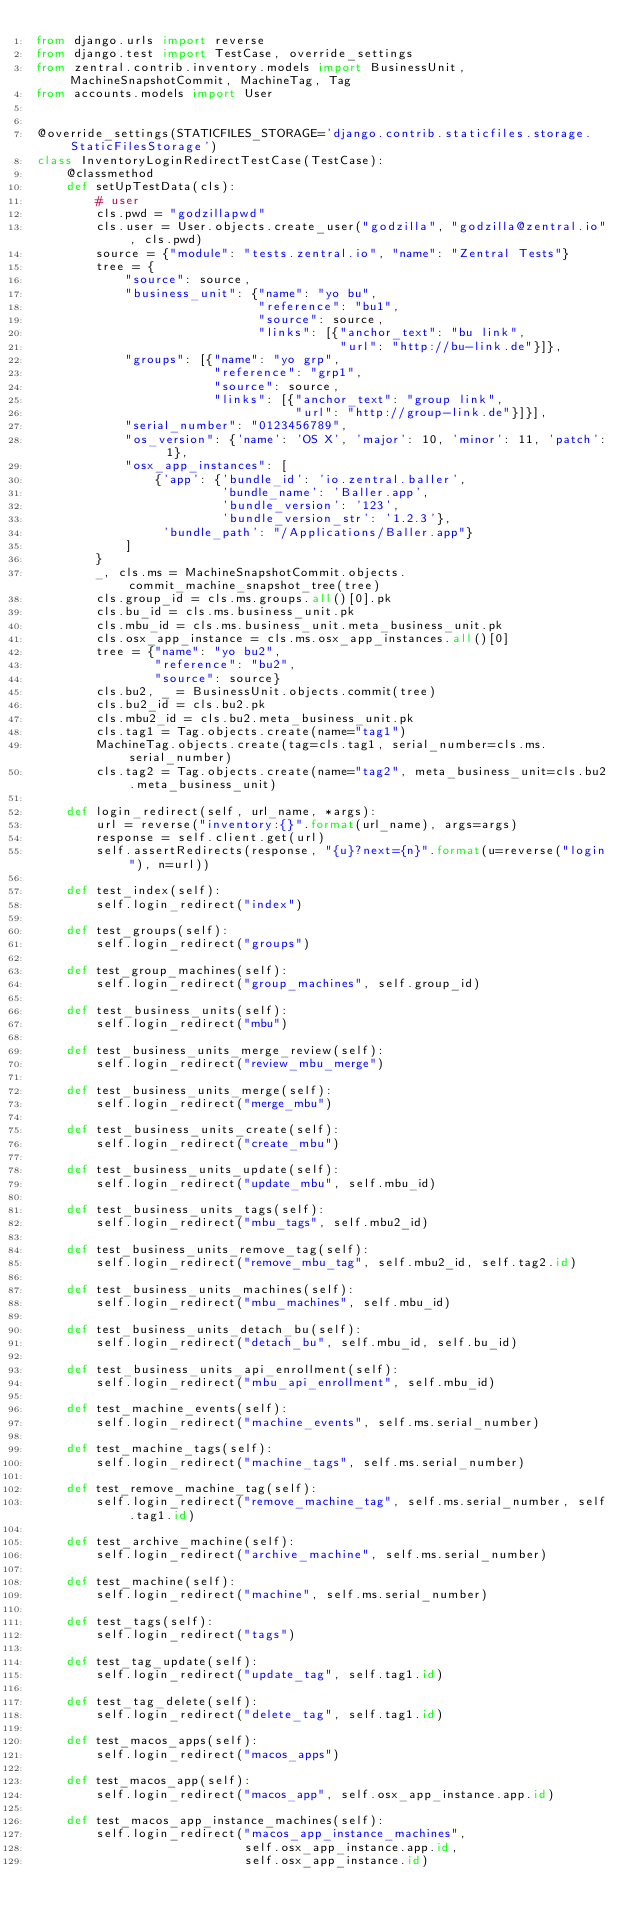Convert code to text. <code><loc_0><loc_0><loc_500><loc_500><_Python_>from django.urls import reverse
from django.test import TestCase, override_settings
from zentral.contrib.inventory.models import BusinessUnit, MachineSnapshotCommit, MachineTag, Tag
from accounts.models import User


@override_settings(STATICFILES_STORAGE='django.contrib.staticfiles.storage.StaticFilesStorage')
class InventoryLoginRedirectTestCase(TestCase):
    @classmethod
    def setUpTestData(cls):
        # user
        cls.pwd = "godzillapwd"
        cls.user = User.objects.create_user("godzilla", "godzilla@zentral.io", cls.pwd)
        source = {"module": "tests.zentral.io", "name": "Zentral Tests"}
        tree = {
            "source": source,
            "business_unit": {"name": "yo bu",
                              "reference": "bu1",
                              "source": source,
                              "links": [{"anchor_text": "bu link",
                                         "url": "http://bu-link.de"}]},
            "groups": [{"name": "yo grp",
                        "reference": "grp1",
                        "source": source,
                        "links": [{"anchor_text": "group link",
                                   "url": "http://group-link.de"}]}],
            "serial_number": "0123456789",
            "os_version": {'name': 'OS X', 'major': 10, 'minor': 11, 'patch': 1},
            "osx_app_instances": [
                {'app': {'bundle_id': 'io.zentral.baller',
                         'bundle_name': 'Baller.app',
                         'bundle_version': '123',
                         'bundle_version_str': '1.2.3'},
                 'bundle_path': "/Applications/Baller.app"}
            ]
        }
        _, cls.ms = MachineSnapshotCommit.objects.commit_machine_snapshot_tree(tree)
        cls.group_id = cls.ms.groups.all()[0].pk
        cls.bu_id = cls.ms.business_unit.pk
        cls.mbu_id = cls.ms.business_unit.meta_business_unit.pk
        cls.osx_app_instance = cls.ms.osx_app_instances.all()[0]
        tree = {"name": "yo bu2",
                "reference": "bu2",
                "source": source}
        cls.bu2, _ = BusinessUnit.objects.commit(tree)
        cls.bu2_id = cls.bu2.pk
        cls.mbu2_id = cls.bu2.meta_business_unit.pk
        cls.tag1 = Tag.objects.create(name="tag1")
        MachineTag.objects.create(tag=cls.tag1, serial_number=cls.ms.serial_number)
        cls.tag2 = Tag.objects.create(name="tag2", meta_business_unit=cls.bu2.meta_business_unit)

    def login_redirect(self, url_name, *args):
        url = reverse("inventory:{}".format(url_name), args=args)
        response = self.client.get(url)
        self.assertRedirects(response, "{u}?next={n}".format(u=reverse("login"), n=url))

    def test_index(self):
        self.login_redirect("index")

    def test_groups(self):
        self.login_redirect("groups")

    def test_group_machines(self):
        self.login_redirect("group_machines", self.group_id)

    def test_business_units(self):
        self.login_redirect("mbu")

    def test_business_units_merge_review(self):
        self.login_redirect("review_mbu_merge")

    def test_business_units_merge(self):
        self.login_redirect("merge_mbu")

    def test_business_units_create(self):
        self.login_redirect("create_mbu")

    def test_business_units_update(self):
        self.login_redirect("update_mbu", self.mbu_id)

    def test_business_units_tags(self):
        self.login_redirect("mbu_tags", self.mbu2_id)

    def test_business_units_remove_tag(self):
        self.login_redirect("remove_mbu_tag", self.mbu2_id, self.tag2.id)

    def test_business_units_machines(self):
        self.login_redirect("mbu_machines", self.mbu_id)

    def test_business_units_detach_bu(self):
        self.login_redirect("detach_bu", self.mbu_id, self.bu_id)

    def test_business_units_api_enrollment(self):
        self.login_redirect("mbu_api_enrollment", self.mbu_id)

    def test_machine_events(self):
        self.login_redirect("machine_events", self.ms.serial_number)

    def test_machine_tags(self):
        self.login_redirect("machine_tags", self.ms.serial_number)

    def test_remove_machine_tag(self):
        self.login_redirect("remove_machine_tag", self.ms.serial_number, self.tag1.id)

    def test_archive_machine(self):
        self.login_redirect("archive_machine", self.ms.serial_number)

    def test_machine(self):
        self.login_redirect("machine", self.ms.serial_number)

    def test_tags(self):
        self.login_redirect("tags")

    def test_tag_update(self):
        self.login_redirect("update_tag", self.tag1.id)

    def test_tag_delete(self):
        self.login_redirect("delete_tag", self.tag1.id)

    def test_macos_apps(self):
        self.login_redirect("macos_apps")

    def test_macos_app(self):
        self.login_redirect("macos_app", self.osx_app_instance.app.id)

    def test_macos_app_instance_machines(self):
        self.login_redirect("macos_app_instance_machines",
                            self.osx_app_instance.app.id,
                            self.osx_app_instance.id)
</code> 